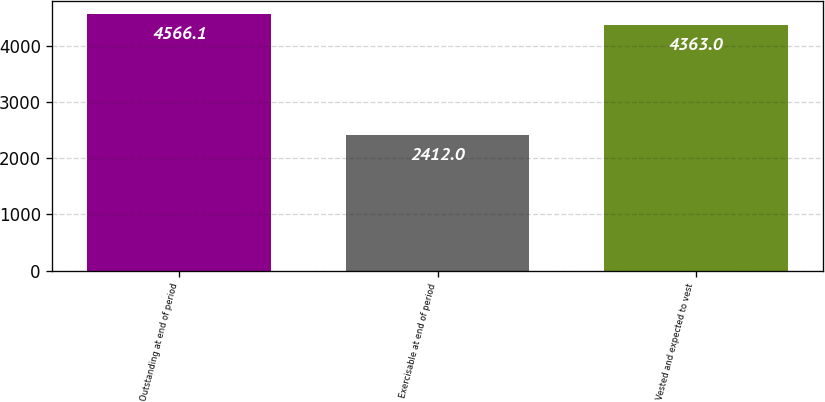<chart> <loc_0><loc_0><loc_500><loc_500><bar_chart><fcel>Outstanding at end of period<fcel>Exercisable at end of period<fcel>Vested and expected to vest<nl><fcel>4566.1<fcel>2412<fcel>4363<nl></chart> 